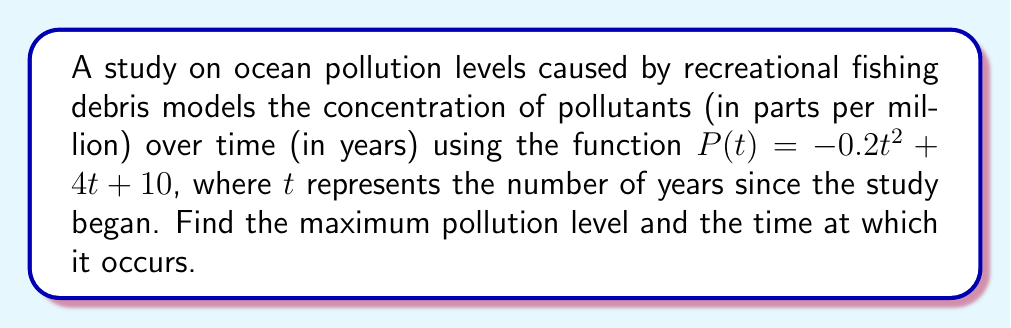Can you solve this math problem? 1) To find the maximum point on the curve, we need to find the derivative of $P(t)$ and set it equal to zero:

   $P'(t) = -0.4t + 4$

2) Set $P'(t) = 0$ and solve for $t$:
   
   $-0.4t + 4 = 0$
   $-0.4t = -4$
   $t = 10$

3) To confirm this is a maximum (not a minimum), check the second derivative:
   
   $P''(t) = -0.4$

   Since $P''(t)$ is negative, the critical point at $t = 10$ is indeed a maximum.

4) Calculate the maximum pollution level by plugging $t = 10$ into the original function:

   $P(10) = -0.2(10)^2 + 4(10) + 10$
          $= -20 + 40 + 10$
          $= 30$

Therefore, the maximum pollution level is 30 ppm, occurring 10 years after the study began.
Answer: Maximum pollution: 30 ppm at t = 10 years 